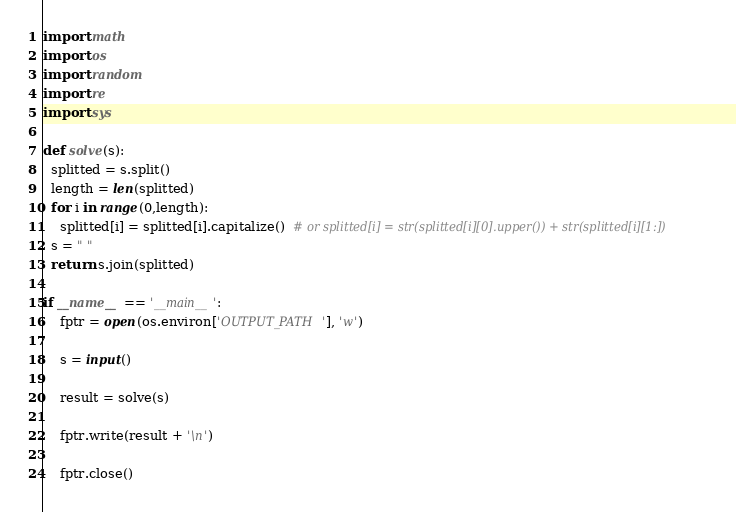Convert code to text. <code><loc_0><loc_0><loc_500><loc_500><_Python_>import math
import os
import random
import re
import sys

def solve(s):
  splitted = s.split()
  length = len(splitted)
  for i in range(0,length):
    splitted[i] = splitted[i].capitalize()  # or splitted[i] = str(splitted[i][0].upper()) + str(splitted[i][1:])
  s = " "
  return s.join(splitted)
  
if __name__ == '__main__':
    fptr = open(os.environ['OUTPUT_PATH'], 'w')

    s = input()

    result = solve(s)

    fptr.write(result + '\n')

    fptr.close()
</code> 